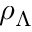Convert formula to latex. <formula><loc_0><loc_0><loc_500><loc_500>\rho _ { \Lambda }</formula> 